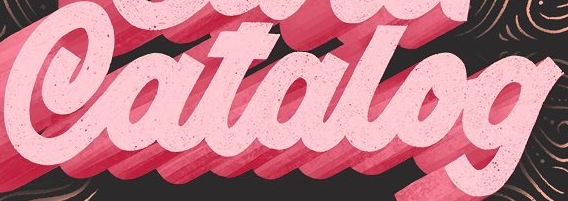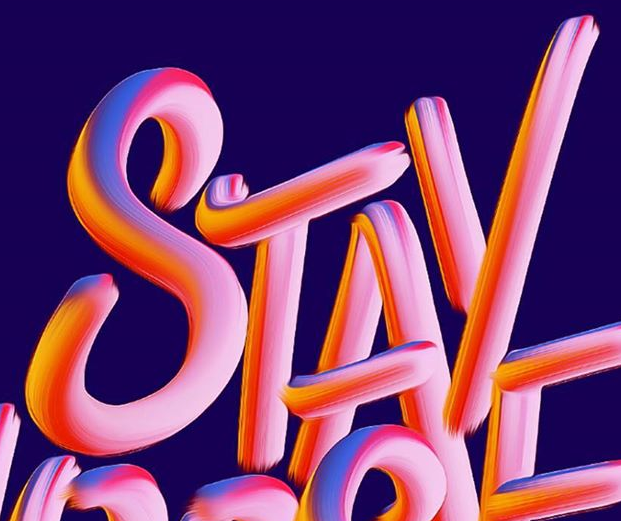What text appears in these images from left to right, separated by a semicolon? Catalog; STAY 